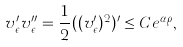<formula> <loc_0><loc_0><loc_500><loc_500>v _ { \epsilon } ^ { \prime } v _ { \epsilon } ^ { \prime \prime } = \frac { 1 } { 2 } ( ( v _ { \epsilon } ^ { \prime } ) ^ { 2 } ) ^ { \prime } \leq C e ^ { \alpha \rho } ,</formula> 